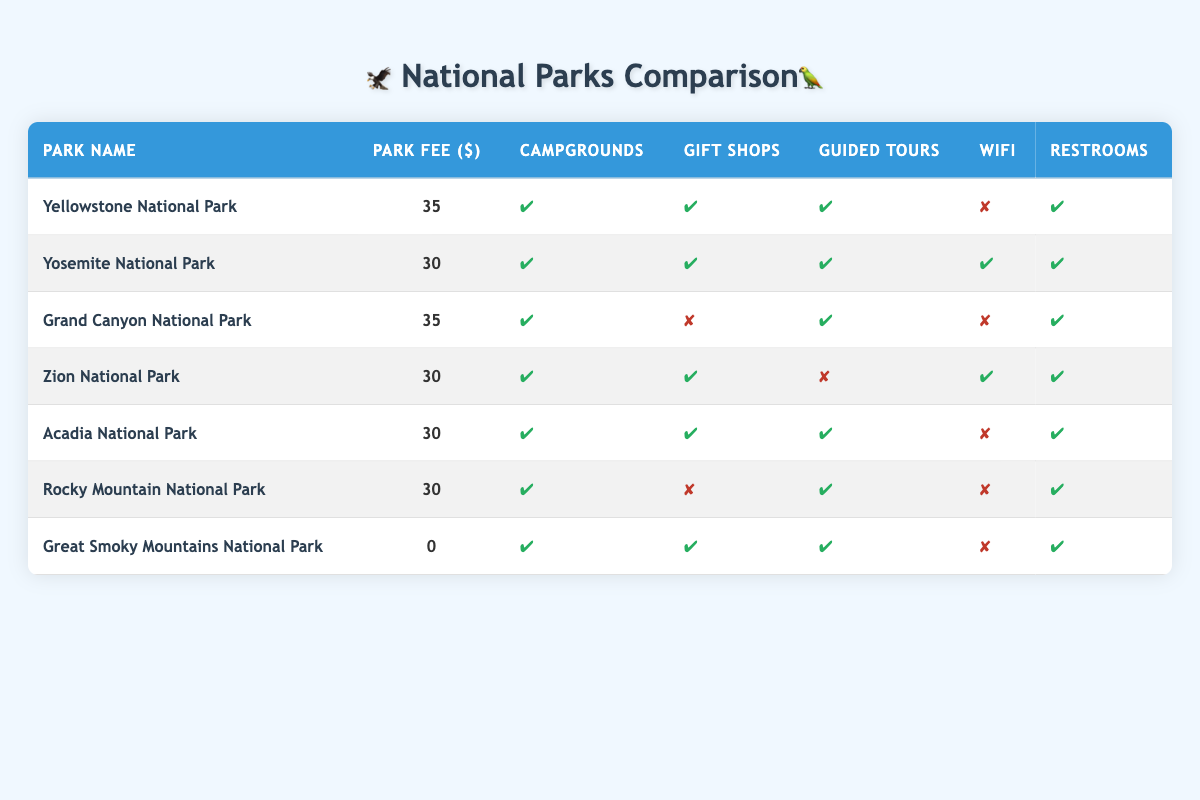What is the park fee for Acadia National Park? The table lists the park fee for each national park, and for Acadia National Park, it is specified as $30.
Answer: $30 Which national parks offer WiFi? By examining the amenities column for each park, I can identify that Yosemite National Park and Zion National Park are the only ones that offer WiFi.
Answer: Yosemite National Park, Zion National Park Is there a park that has no fee? The table indicates that Great Smoky Mountains National Park has a park fee of $0, meaning that it has no entrance fee.
Answer: Yes How many parks have guided tours available? Counting the parks in the table, Yellowstone, Yosemite, Grand Canyon, Acadia, Rocky Mountain, and Great Smoky all have guided tours, totaling 6 parks with this amenity.
Answer: 6 What is the average park fee for parks that have campgrounds? First, I identify the parks with campgrounds: Yellowstone, Yosemite, Grand Canyon, Zion, Acadia, Rocky Mountain, and Great Smoky. Their fees are $35, $30, $35, $30, $30, $30, and $0, respectively. The total fee is $35 + $30 + $35 + $30 + $30 + $30 + $0 = $220. There are 7 parks, so the average is $220 / 7 = $31.43.
Answer: $31.43 Which national park has the highest fee and what amenities does it provide? The highest fee is $35, which is charged by both Yellowstone National Park and Grand Canyon National Park. Yellowstone offers campgrounds, gift shops, guided tours, and restrooms, but no WiFi. Grand Canyon offers campgrounds, guided tours, and restrooms but lacks gift shops and WiFi.
Answer: Yellowstone and Grand Canyon; Amenities listed Do any national parks provide gift shops but not guided tours? By inspecting the amenities, I find that Grand Canyon National Park does not have gift shops and Zion National Park does not offer guided tours. However, the only park that has gift shops without guided tours is Grand Canyon National Park.
Answer: Yes, Grand Canyon National Park How many parks offer restrooms but do not provide WiFi? The parks that have restrooms but do not provide WiFi are Yellowstone, Grand Canyon, Acadia, Rocky Mountain, and Great Smoky. Checking the amenities, I find a total of 5 parks meeting this criterion.
Answer: 5 Which park has the lowest fee, and does it provide campgrounds? Looking at the fee column, Great Smoky Mountains National Park has the lowest fee at $0. According to the amenities section, it does indeed provide campgrounds, confirming the existence of this facility.
Answer: Yes, Great Smoky Mountains National Park 